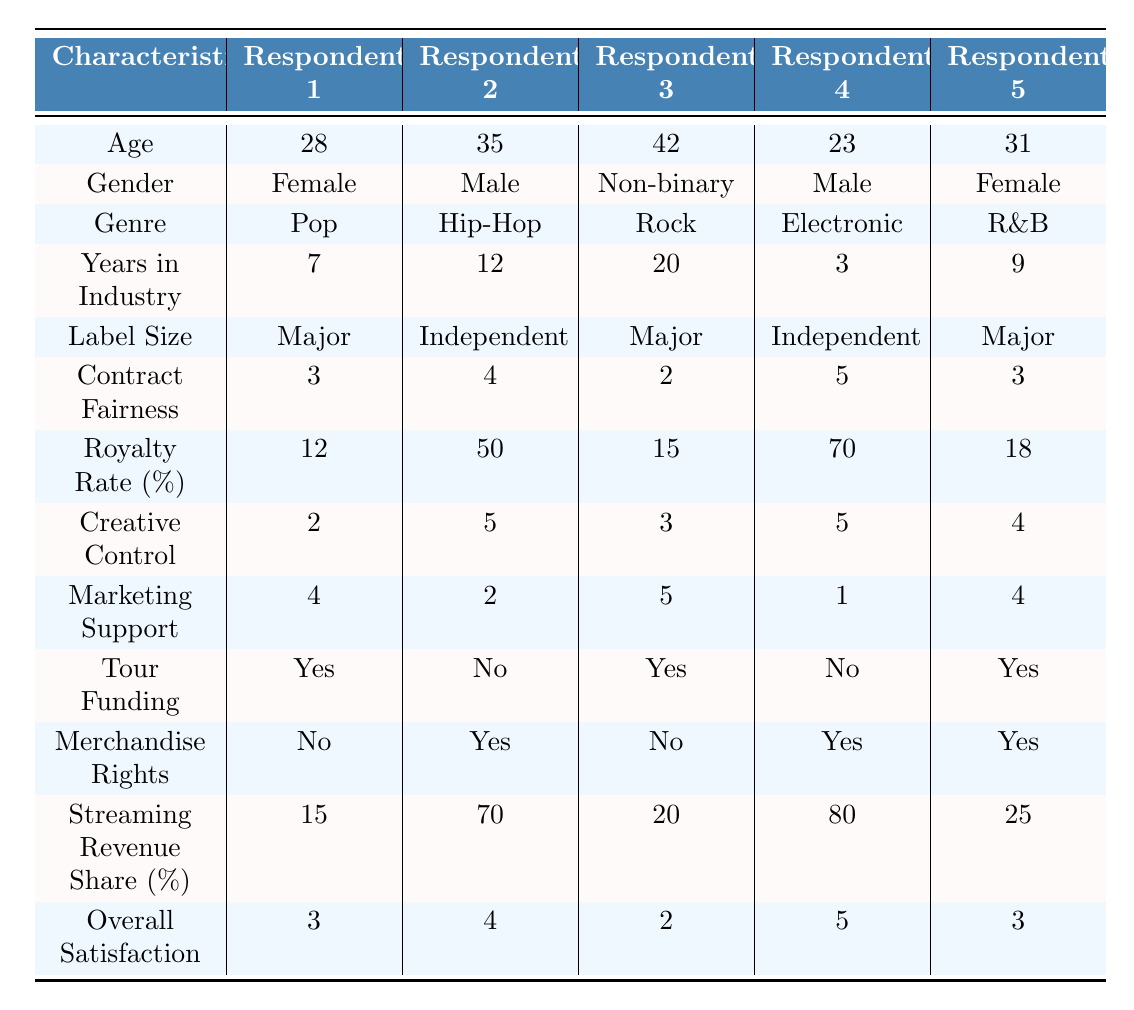What is the average age of the respondents? The ages of the respondents are 28, 35, 42, 23, and 31. Adding these together gives 28 + 35 + 42 + 23 + 31 = 159. There are 5 respondents, so the average age is 159/5 = 31.8.
Answer: 31.8 Which respondent has the highest royalty rate? The royalty rates for the respondents are 12%, 50%, 15%, 70%, and 18%. The highest among these is 70%, which corresponds to Respondent 4.
Answer: Respondent 4 Is there any respondent who has both tour funding and merchandise rights? Respondent 1 has tour funding (Yes) but does not have merchandise rights (No). Respondent 2 has merchandise rights (Yes) but does not have tour funding (No). Similarly, Respondent 5 has both tour funding (Yes) and merchandise rights (Yes).
Answer: Yes What is the difference between the highest and lowest scores in overall satisfaction? The overall satisfaction scores are 3, 4, 2, 5, and 3. The highest score is 5, and the lowest is 2. The difference is 5 - 2 = 3.
Answer: 3 How many respondents are from major record labels? The respondents from major labels are Respondents 1, 3, and 5. Counting these gives a total of 3 respondents from major labels.
Answer: 3 Which genre has the highest average contract fairness score? The contract fairness scores for each genre are: Pop (3), Hip-Hop (4), Rock (2), Electronic (5), and R&B (3). The average for Electronic is the highest at 5.
Answer: Electronic Does a higher royal rate correlate with higher overall satisfaction? Respondent 2 has a high royalty rate of 50% and a satisfaction of 4. Respondent 4 has the highest royalty rate of 70% and satisfaction of 5. In contrast, Respondents 1, 3, and 5 have lower royalty rates (12%, 15%, and 18%, respectively) with satisfaction scores of 3, 2, and 3. This suggests some correlation but isn't definitive as there are exceptions.
Answer: Yes, but not definitively What percentage of respondents report having very low contract transparency? According to the data, 25 respondents reported very low contract transparency. To find the percentage, divide by the total number of respondents: (25/1500) * 100 = 1.67%.
Answer: 1.67% How many respondents have high or very high creative control? The scores for creative control are 2, 5, 3, 5, and 4. High means 4 or 5. Respondents 2, 4, and 5 meet this criterion. Counting these gives us 3 respondents.
Answer: 3 What is the proportion of independent record label respondents with marketing support of 1? Respondent 4 (Independent) has a marketing support score of 1, and out of a total of 1500 respondents, the independent label respondents total 2 (Respondents 2 and 4). The proportion is 1 out of 2, or 50%.
Answer: 50% 